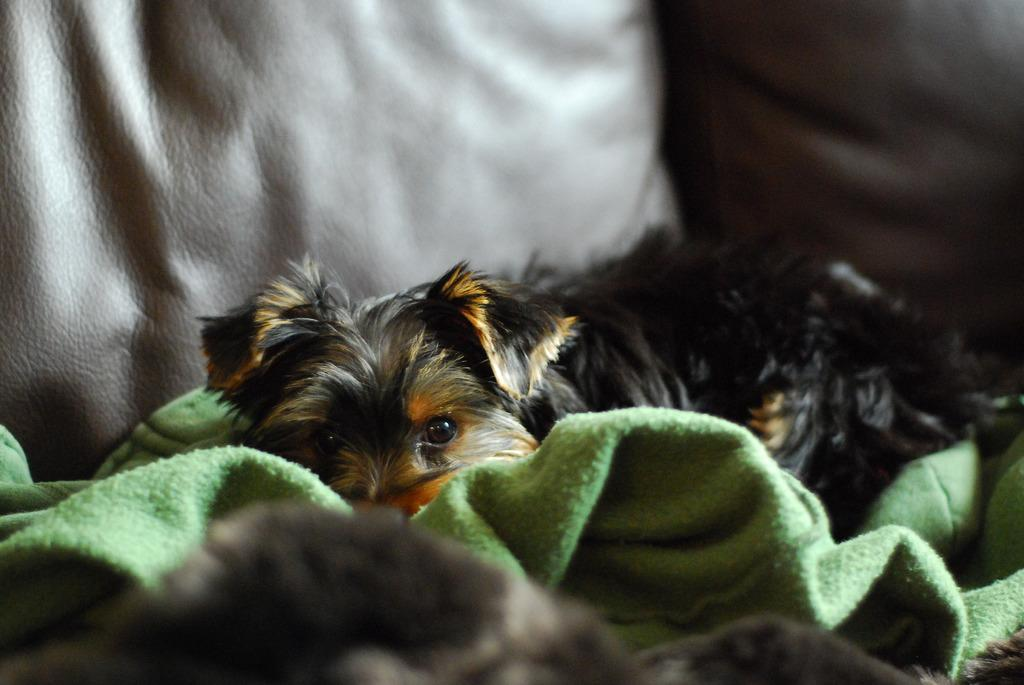What type of animal is in the picture? There is a dog in the picture. What color is the dog? The dog is black in color. What is the dog laying on? The dog is laying on a green cloth. Can you describe the object behind the dog? There is a pillow visible behind the dog. What type of cattle can be seen grazing in the ocean in the image? There is no cattle or ocean present in the image; it features a black dog laying on a green cloth with a pillow behind it. 